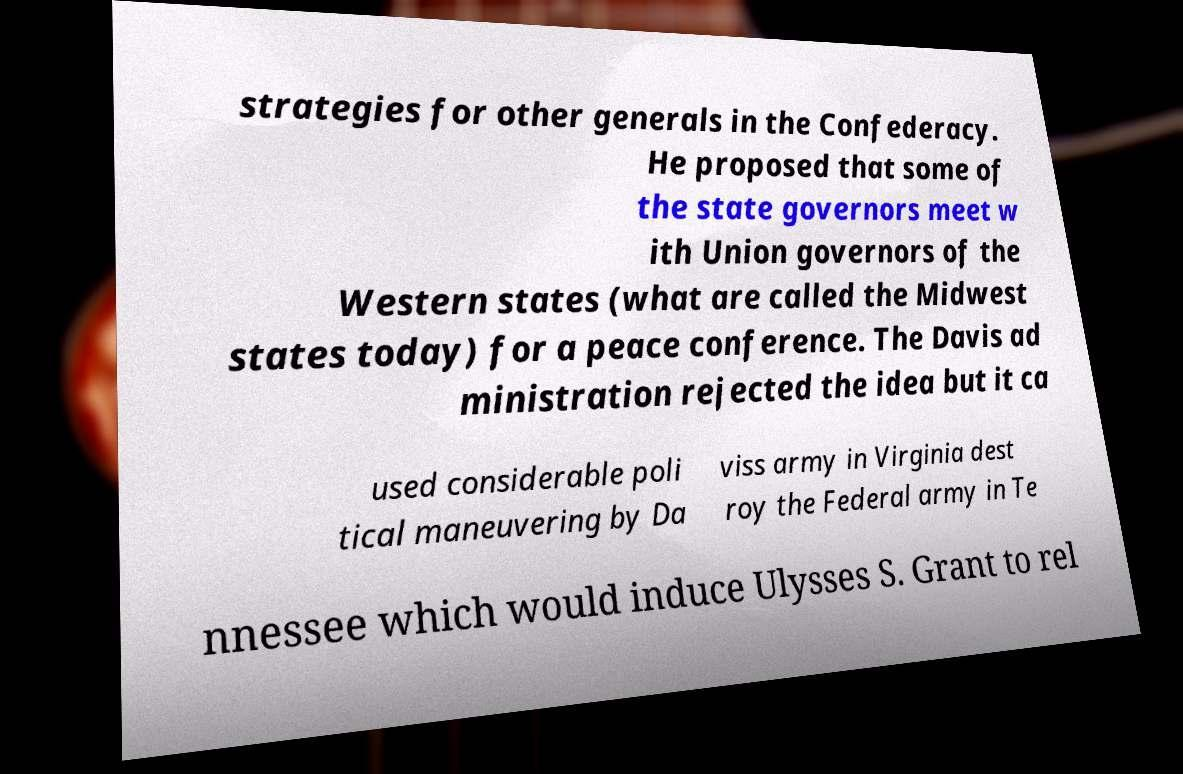Please identify and transcribe the text found in this image. strategies for other generals in the Confederacy. He proposed that some of the state governors meet w ith Union governors of the Western states (what are called the Midwest states today) for a peace conference. The Davis ad ministration rejected the idea but it ca used considerable poli tical maneuvering by Da viss army in Virginia dest roy the Federal army in Te nnessee which would induce Ulysses S. Grant to rel 